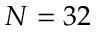<formula> <loc_0><loc_0><loc_500><loc_500>N = 3 2</formula> 